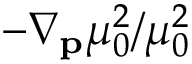Convert formula to latex. <formula><loc_0><loc_0><loc_500><loc_500>- \nabla _ { p } \mu _ { 0 } ^ { 2 } / \mu _ { 0 } ^ { 2 }</formula> 